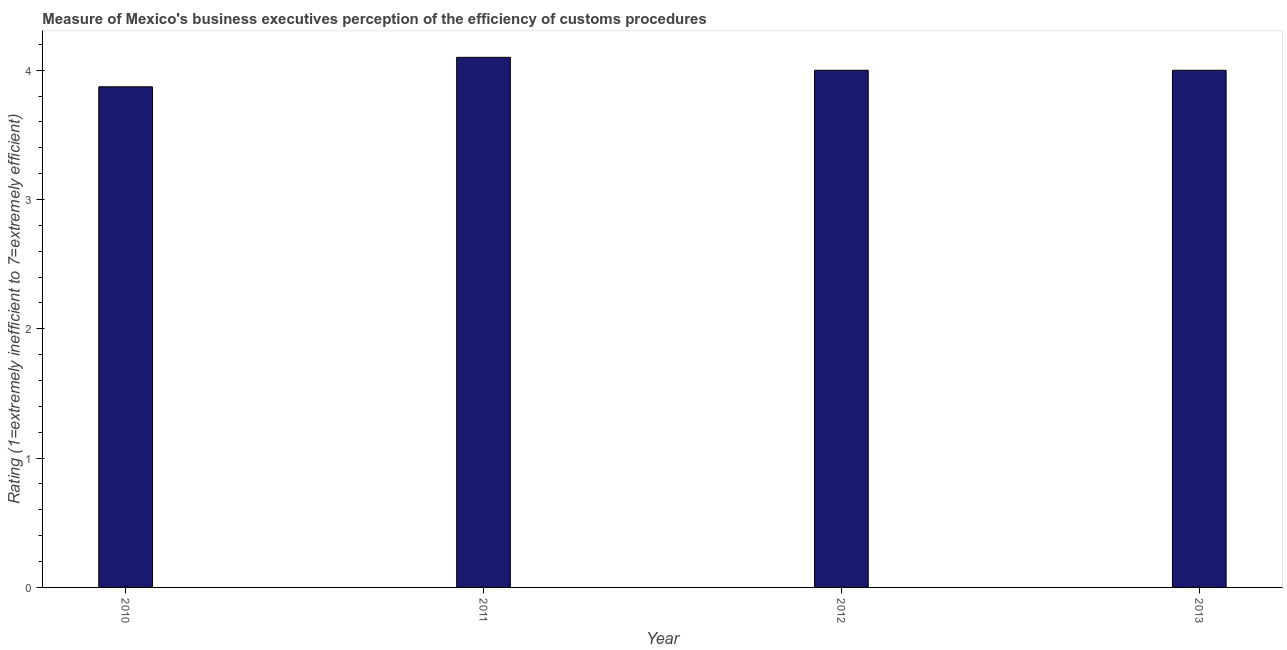Does the graph contain any zero values?
Give a very brief answer. No. What is the title of the graph?
Provide a short and direct response. Measure of Mexico's business executives perception of the efficiency of customs procedures. What is the label or title of the X-axis?
Give a very brief answer. Year. What is the label or title of the Y-axis?
Make the answer very short. Rating (1=extremely inefficient to 7=extremely efficient). What is the rating measuring burden of customs procedure in 2011?
Ensure brevity in your answer.  4.1. Across all years, what is the minimum rating measuring burden of customs procedure?
Make the answer very short. 3.87. In which year was the rating measuring burden of customs procedure maximum?
Provide a short and direct response. 2011. What is the sum of the rating measuring burden of customs procedure?
Offer a terse response. 15.97. What is the difference between the rating measuring burden of customs procedure in 2010 and 2012?
Your answer should be very brief. -0.13. What is the average rating measuring burden of customs procedure per year?
Make the answer very short. 3.99. What is the median rating measuring burden of customs procedure?
Offer a terse response. 4. Do a majority of the years between 2011 and 2012 (inclusive) have rating measuring burden of customs procedure greater than 1 ?
Make the answer very short. Yes. What is the ratio of the rating measuring burden of customs procedure in 2010 to that in 2013?
Keep it short and to the point. 0.97. Is the rating measuring burden of customs procedure in 2011 less than that in 2012?
Keep it short and to the point. No. Is the difference between the rating measuring burden of customs procedure in 2012 and 2013 greater than the difference between any two years?
Make the answer very short. No. What is the difference between the highest and the second highest rating measuring burden of customs procedure?
Ensure brevity in your answer.  0.1. What is the difference between the highest and the lowest rating measuring burden of customs procedure?
Offer a very short reply. 0.23. In how many years, is the rating measuring burden of customs procedure greater than the average rating measuring burden of customs procedure taken over all years?
Keep it short and to the point. 3. How many bars are there?
Give a very brief answer. 4. Are all the bars in the graph horizontal?
Your answer should be very brief. No. What is the difference between two consecutive major ticks on the Y-axis?
Provide a succinct answer. 1. Are the values on the major ticks of Y-axis written in scientific E-notation?
Ensure brevity in your answer.  No. What is the Rating (1=extremely inefficient to 7=extremely efficient) of 2010?
Give a very brief answer. 3.87. What is the Rating (1=extremely inefficient to 7=extremely efficient) in 2011?
Offer a very short reply. 4.1. What is the Rating (1=extremely inefficient to 7=extremely efficient) of 2012?
Your answer should be very brief. 4. What is the difference between the Rating (1=extremely inefficient to 7=extremely efficient) in 2010 and 2011?
Offer a very short reply. -0.23. What is the difference between the Rating (1=extremely inefficient to 7=extremely efficient) in 2010 and 2012?
Ensure brevity in your answer.  -0.13. What is the difference between the Rating (1=extremely inefficient to 7=extremely efficient) in 2010 and 2013?
Offer a very short reply. -0.13. What is the ratio of the Rating (1=extremely inefficient to 7=extremely efficient) in 2010 to that in 2011?
Keep it short and to the point. 0.94. What is the ratio of the Rating (1=extremely inefficient to 7=extremely efficient) in 2010 to that in 2012?
Offer a very short reply. 0.97. 